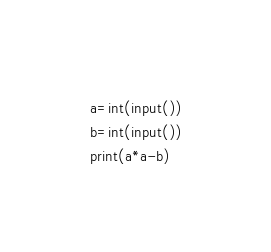<code> <loc_0><loc_0><loc_500><loc_500><_Python_>a=int(input())
b=int(input())
print(a*a-b)</code> 